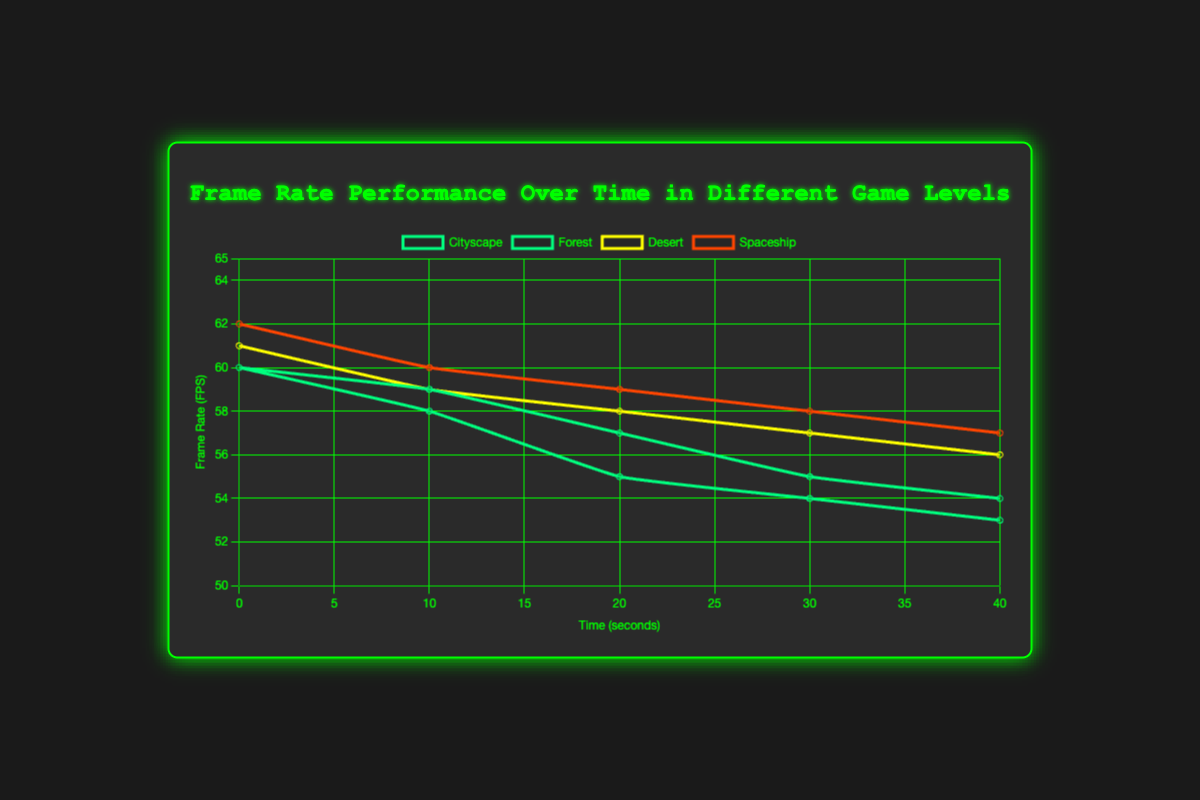What’s the average frame rate drop in the Cityscape level over the first 40 seconds? To find the average frame rate drop, we first note the frame rates at 0 and 40 seconds: 60 FPS and 53 FPS, respectively. The drop is 60 - 53 = 7 FPS over 40 seconds. The average drop per 10 seconds is then 7 FPS / 4 intervals = 1.75 FPS.
Answer: 1.75 FPS Which level experiences the smallest overall frame rate decrease over time? We need to compare the initial and final frame rates for all levels. For the Cityscape level, it drops from 60 to 53 FPS (7 FPS drop); Forest, from 60 to 54 FPS (6 FPS drop); Desert, from 61 to 56 FPS (5 FPS drop); Spaceship, from 62 to 57 FPS (5 FPS drop). The Desert and Spaceship levels experience the smallest drop of 5 FPS each.
Answer: Desert and Spaceship Which level starts with the highest frame rate? By observing the frame rate at time 0 seconds for all levels, the Spaceship level starts at the highest frame rate of 62 FPS.
Answer: Spaceship How much total frame rate drop does the Forest level experience in its first 30 seconds? For the Forest level, the frame rate at 0 seconds is 60 FPS and at 30 seconds it is 55 FPS. The total frame rate drop is 60 - 55 = 5 FPS.
Answer: 5 FPS Over the first 20 seconds, which level's frame rate decreases the fastest? Comparing frame rate drops at 20 seconds for each level: Cityscape drops by 60 - 55 = 5 FPS; Forest drops by 60 - 57 = 3 FPS; Desert drops by 61 - 58 = 3 FPS; Spaceship drops by 62 - 59 = 3 FPS. The Cityscape level has the fastest decrease of 5 FPS over the first 20 seconds.
Answer: Cityscape How far apart are the frame rates of the Desert and Forest levels at 40 seconds? At 40 seconds, Desert’s frame rate is 56 FPS and Forest’s frame rate is 54 FPS. The difference in frame rates is 56 - 54 = 2 FPS.
Answer: 2 FPS Which level maintains a frame rate consistently above 55 FPS throughout the time series? By examining the frame rate values over time, we see that only the Desert and Spaceship levels both maintain their frame rates above 55 FPS from 0 to 40 seconds.
Answer: Desert and Spaceship 